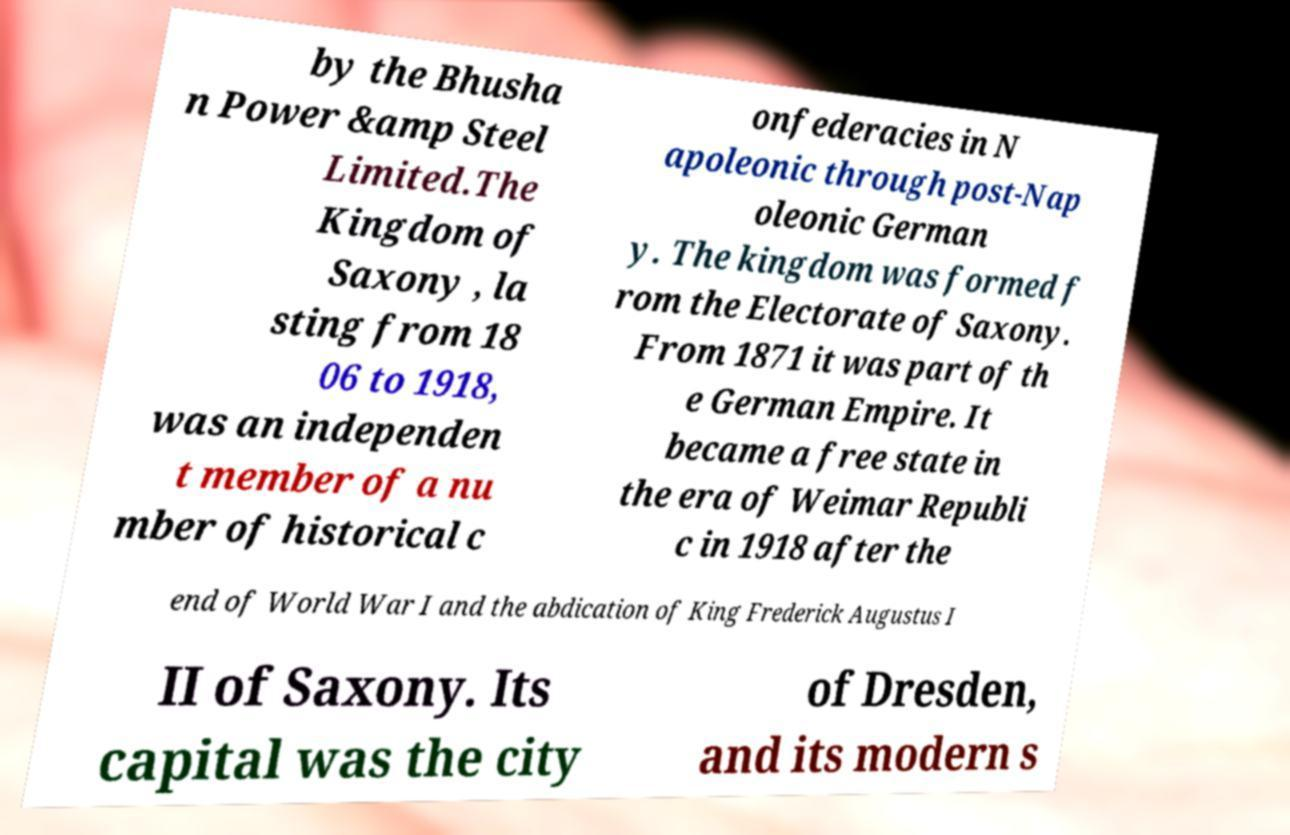I need the written content from this picture converted into text. Can you do that? by the Bhusha n Power &amp Steel Limited.The Kingdom of Saxony , la sting from 18 06 to 1918, was an independen t member of a nu mber of historical c onfederacies in N apoleonic through post-Nap oleonic German y. The kingdom was formed f rom the Electorate of Saxony. From 1871 it was part of th e German Empire. It became a free state in the era of Weimar Republi c in 1918 after the end of World War I and the abdication of King Frederick Augustus I II of Saxony. Its capital was the city of Dresden, and its modern s 